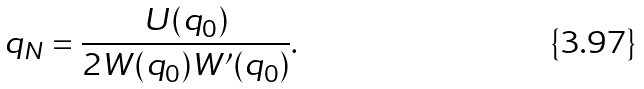<formula> <loc_0><loc_0><loc_500><loc_500>q _ { N } = \frac { U ( q _ { 0 } ) } { 2 W ( q _ { 0 } ) W ^ { \prime } ( q _ { 0 } ) } .</formula> 